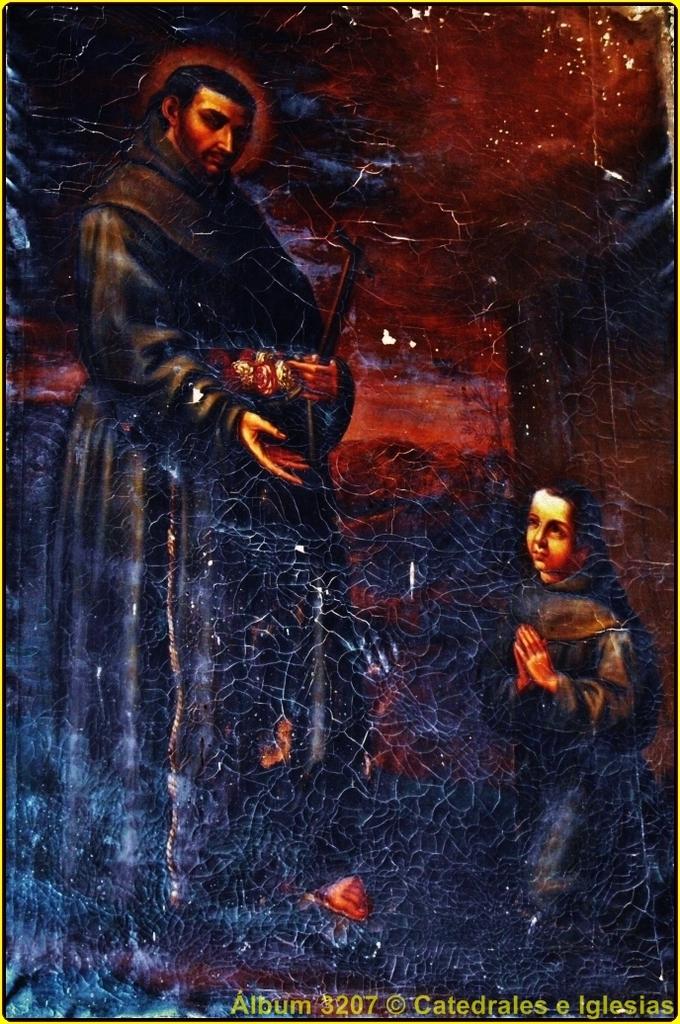Who is this copyrighted by?
Give a very brief answer. Catedrales e iglesias. What do the yellow words say?
Keep it short and to the point. Album 3207 catedrales e iglesias. 